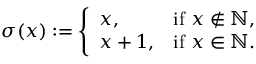<formula> <loc_0><loc_0><loc_500><loc_500>\sigma ( x ) \colon = { \left \{ \begin{array} { l l } { x , } & { { i f } x \not \in \mathbb { N } , } \\ { x + 1 , } & { { i f } x \in \mathbb { N } . } \end{array} }</formula> 